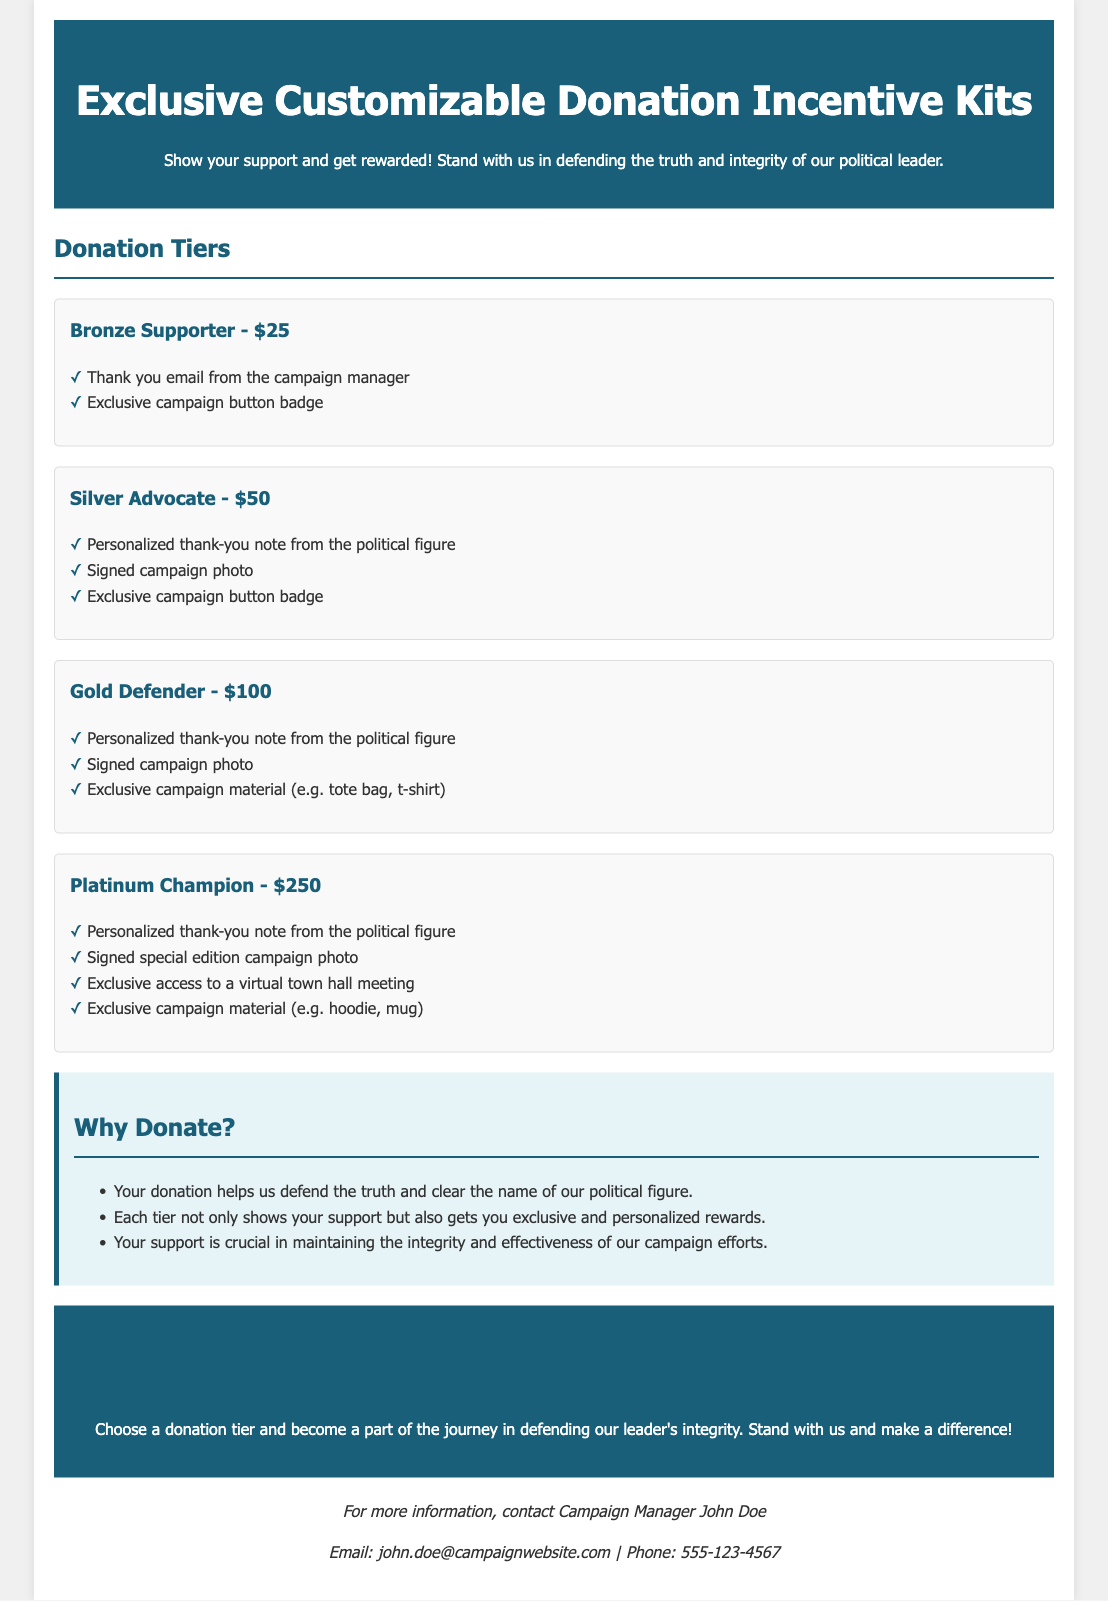What is the title of the document? The title is stated in the <title> tag of the document, which is "Exclusive Customizable Donation Incentive Kits".
Answer: Exclusive Customizable Donation Incentive Kits What is the highest donation tier? The highest tier is found in the section titled "Donation Tiers", which is "Platinum Champion - $250".
Answer: Platinum Champion - $250 What reward does a Silver Advocate receive? The rewards for a Silver Advocate tier are listed under that section, which includes a "Personalized thank-you note from the political figure".
Answer: Personalized thank-you note from the political figure How many donation tiers are listed in the document? The document lists four distinct donation tiers in the "Donation Tiers" section.
Answer: Four What type of item is included in the Gold Defender tier? The Gold Defender tier includes "Exclusive campaign material (e.g. tote bag, t-shirt)" as one of its incentives.
Answer: Exclusive campaign material (e.g. tote bag, t-shirt) What incentive do all tiers offer? By analyzing the listed tiers, all of them offer a personalized reward which is found consistently across different tiers.
Answer: Personalized thank-you note from the political figure Who is the contact person for more information? The document specifies the Campaign Manager's name in the contact section, which is "John Doe".
Answer: John Doe What is the purpose of donating described in the document? The reasons to donate are outlined in the "Why Donate?" section, emphasizing the defense of the political figure's truth and integrity.
Answer: Defend the truth and clear the name of our political figure 